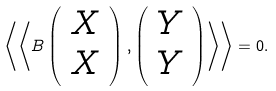Convert formula to latex. <formula><loc_0><loc_0><loc_500><loc_500>\left \langle \left \langle B \left ( \begin{array} { c } { X } \\ { X } \end{array} \right ) , \left ( \begin{array} { c } { Y } \\ { Y } \end{array} \right ) \right \rangle \right \rangle = 0 .</formula> 